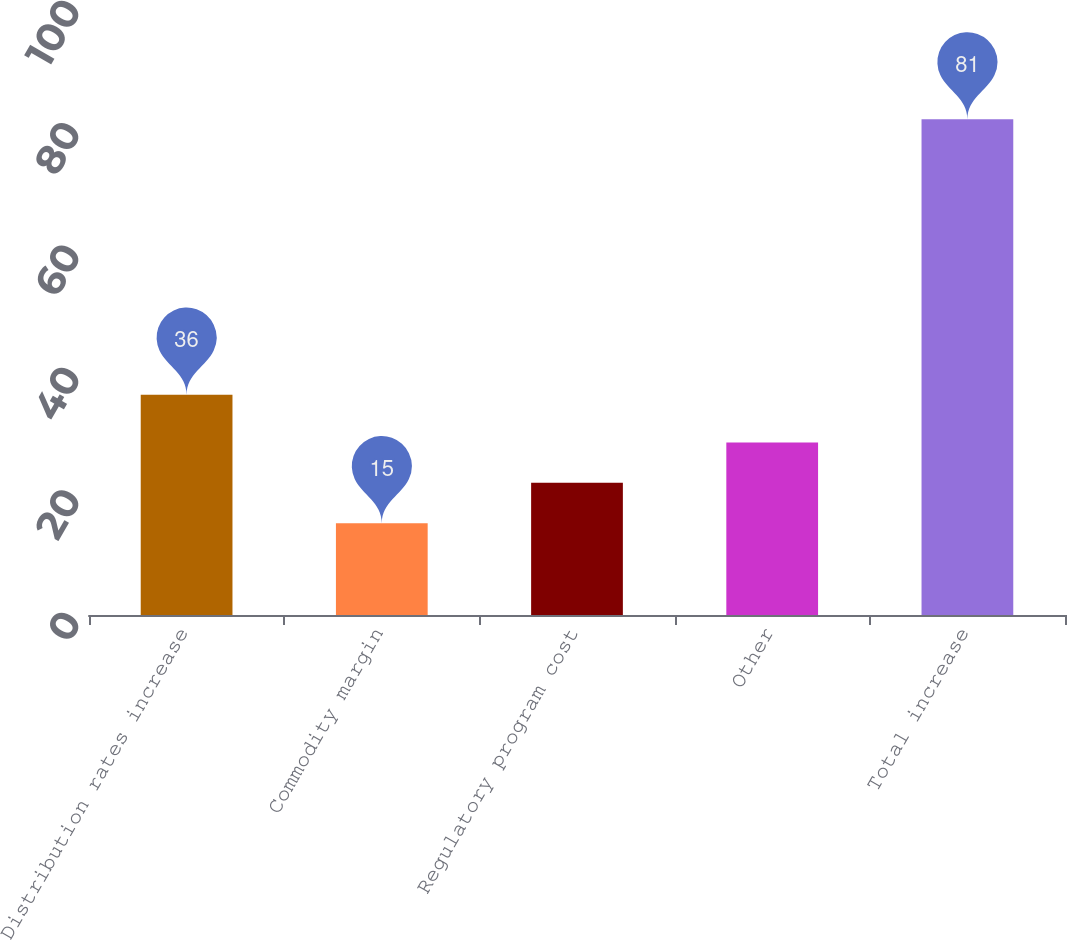Convert chart. <chart><loc_0><loc_0><loc_500><loc_500><bar_chart><fcel>Distribution rates increase<fcel>Commodity margin<fcel>Regulatory program cost<fcel>Other<fcel>Total increase<nl><fcel>36<fcel>15<fcel>21.6<fcel>28.2<fcel>81<nl></chart> 